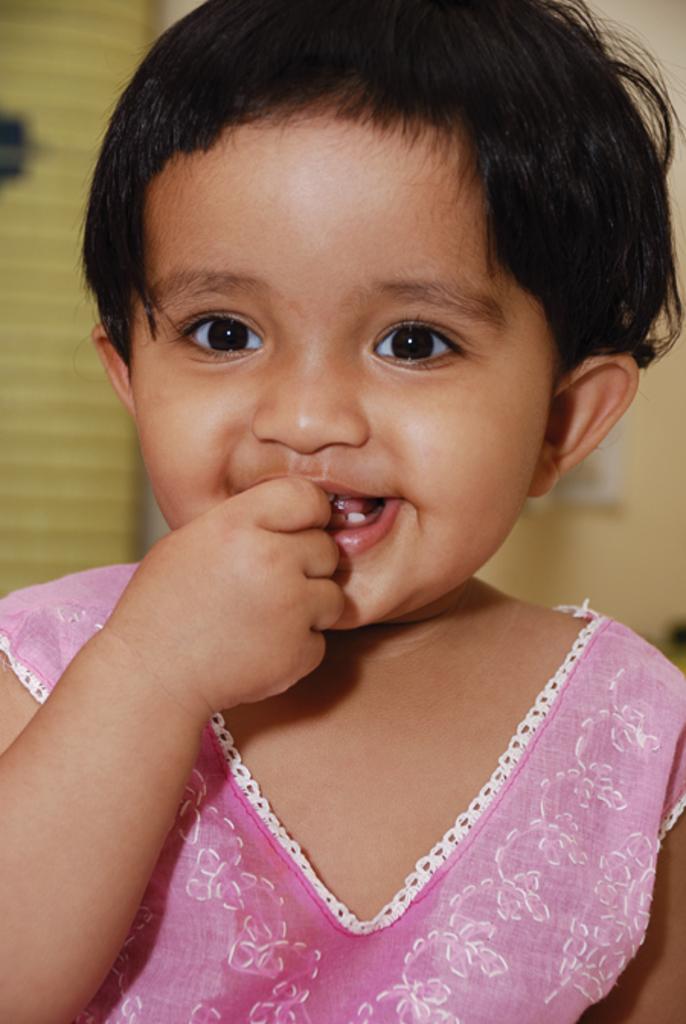Describe this image in one or two sentences. In the image there is a baby in pink dress smiling and in the back there is wall. 